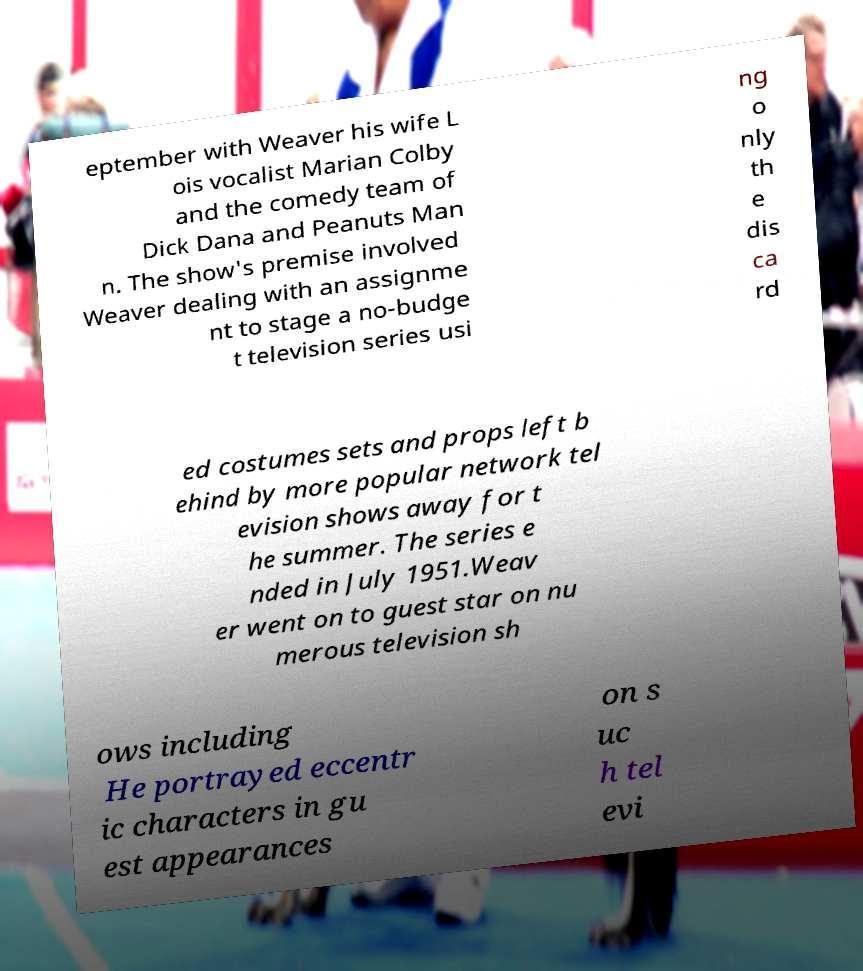For documentation purposes, I need the text within this image transcribed. Could you provide that? eptember with Weaver his wife L ois vocalist Marian Colby and the comedy team of Dick Dana and Peanuts Man n. The show's premise involved Weaver dealing with an assignme nt to stage a no-budge t television series usi ng o nly th e dis ca rd ed costumes sets and props left b ehind by more popular network tel evision shows away for t he summer. The series e nded in July 1951.Weav er went on to guest star on nu merous television sh ows including He portrayed eccentr ic characters in gu est appearances on s uc h tel evi 